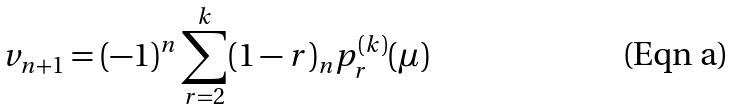<formula> <loc_0><loc_0><loc_500><loc_500>v _ { n + 1 } = ( - 1 ) ^ { n } \sum _ { r = 2 } ^ { k } ( 1 - r ) _ { n } p _ { r } ^ { ( k ) } ( \mu )</formula> 